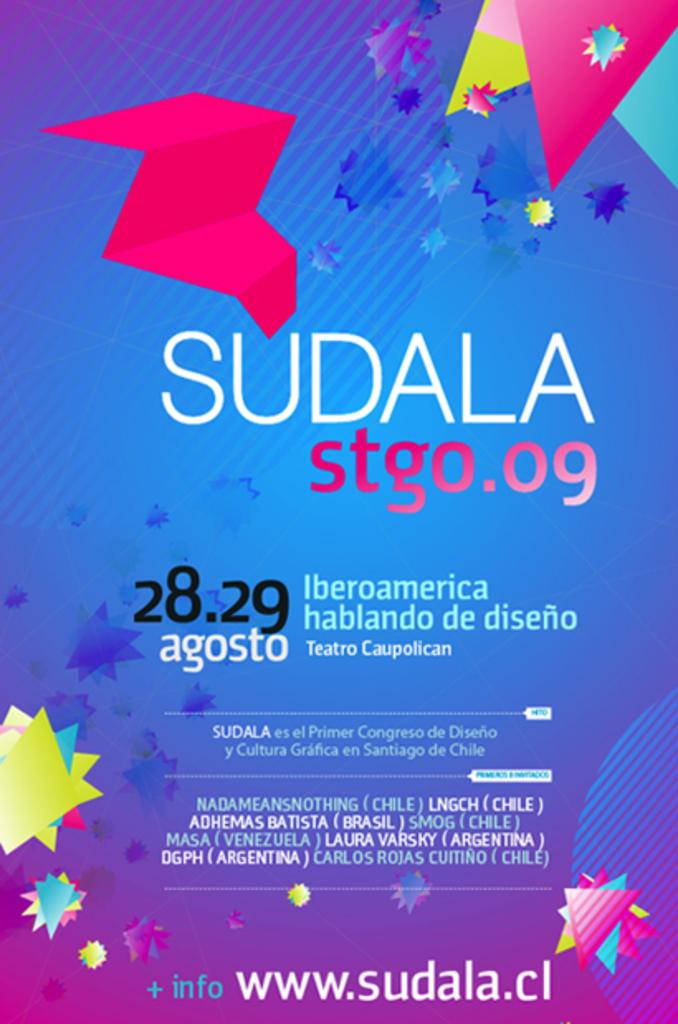Provide a one-sentence caption for the provided image. An advertisement for Sudala showing more info can be found at www.sudala.cl. 